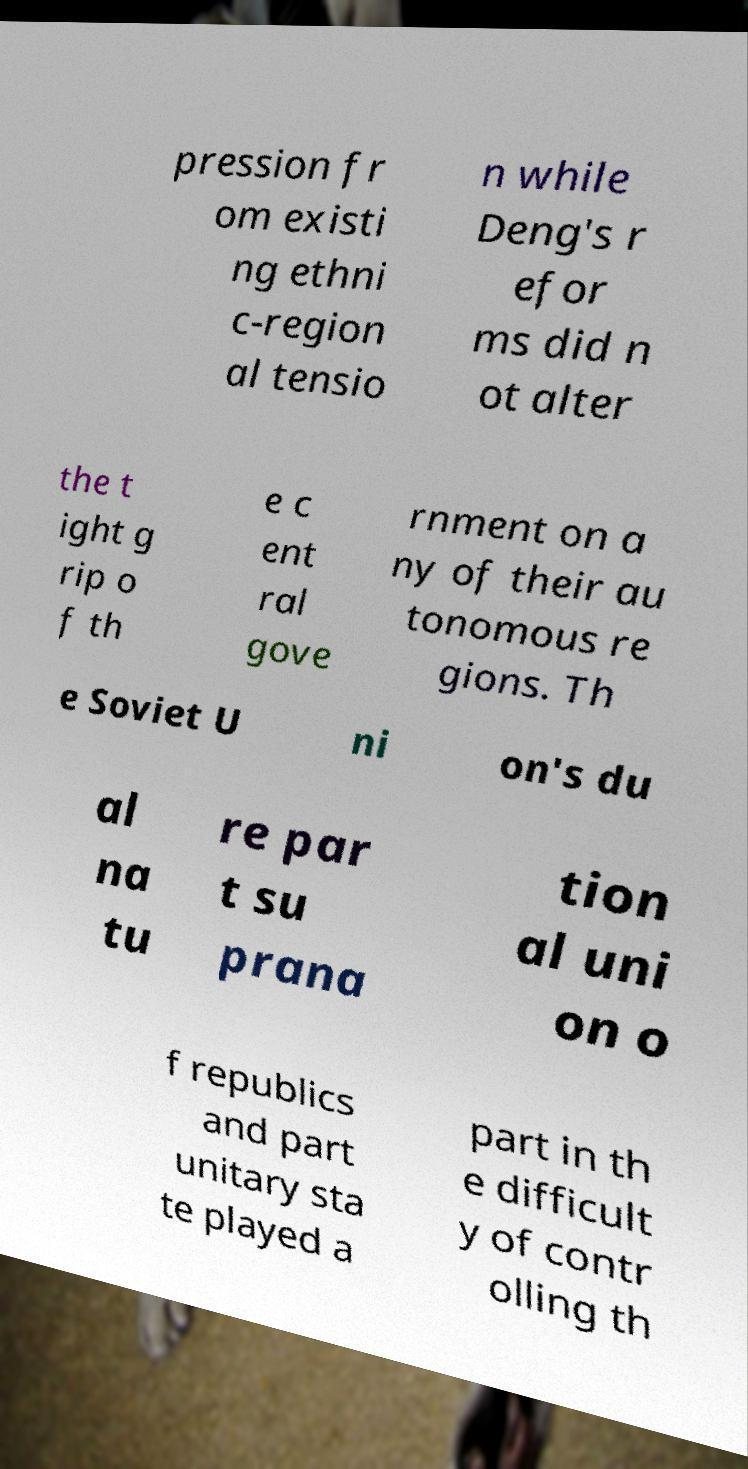What messages or text are displayed in this image? I need them in a readable, typed format. pression fr om existi ng ethni c-region al tensio n while Deng's r efor ms did n ot alter the t ight g rip o f th e c ent ral gove rnment on a ny of their au tonomous re gions. Th e Soviet U ni on's du al na tu re par t su prana tion al uni on o f republics and part unitary sta te played a part in th e difficult y of contr olling th 